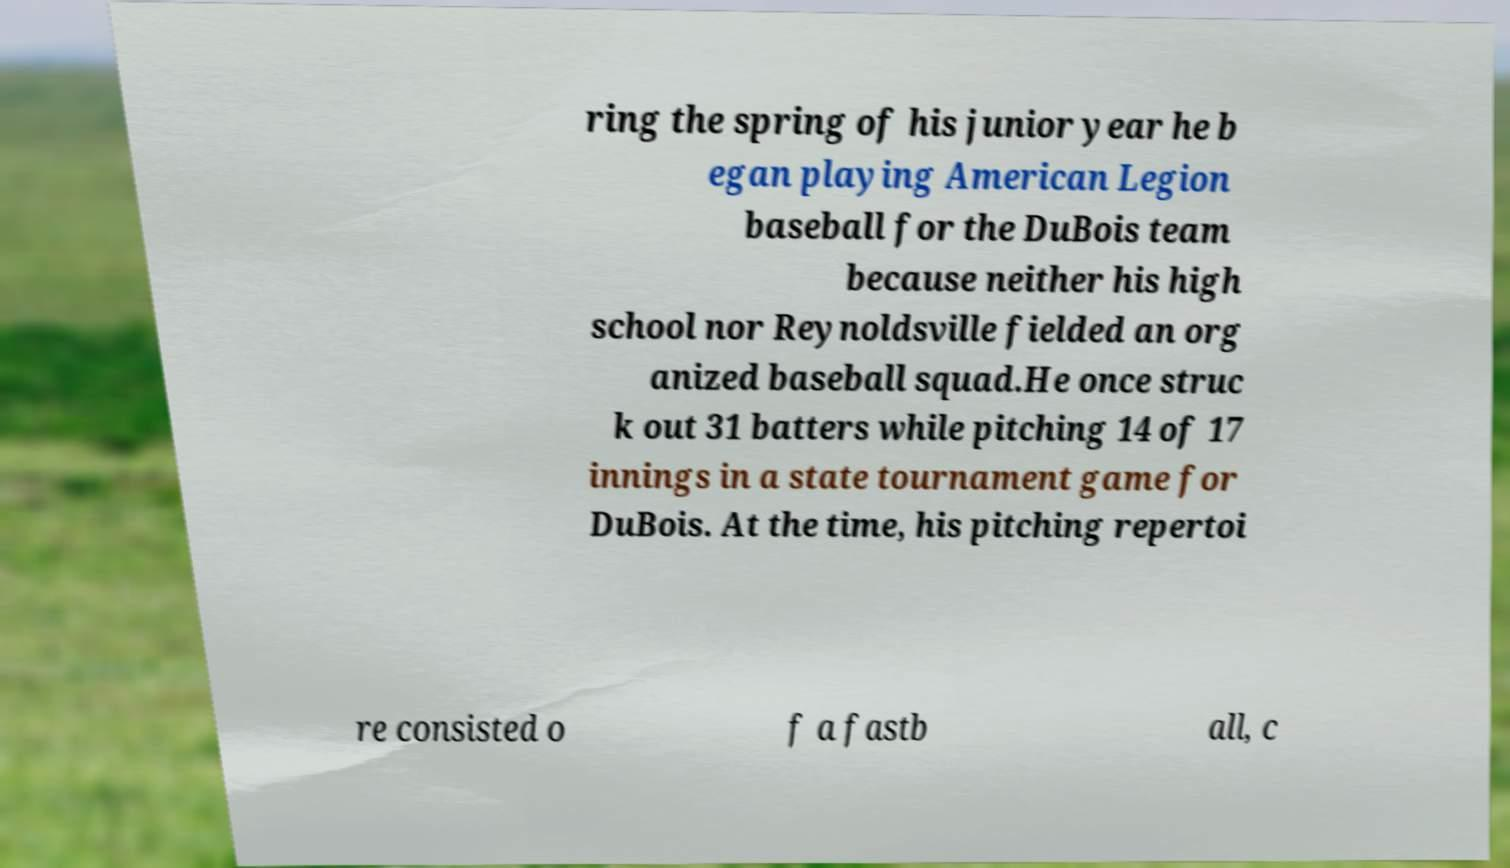Please identify and transcribe the text found in this image. ring the spring of his junior year he b egan playing American Legion baseball for the DuBois team because neither his high school nor Reynoldsville fielded an org anized baseball squad.He once struc k out 31 batters while pitching 14 of 17 innings in a state tournament game for DuBois. At the time, his pitching repertoi re consisted o f a fastb all, c 